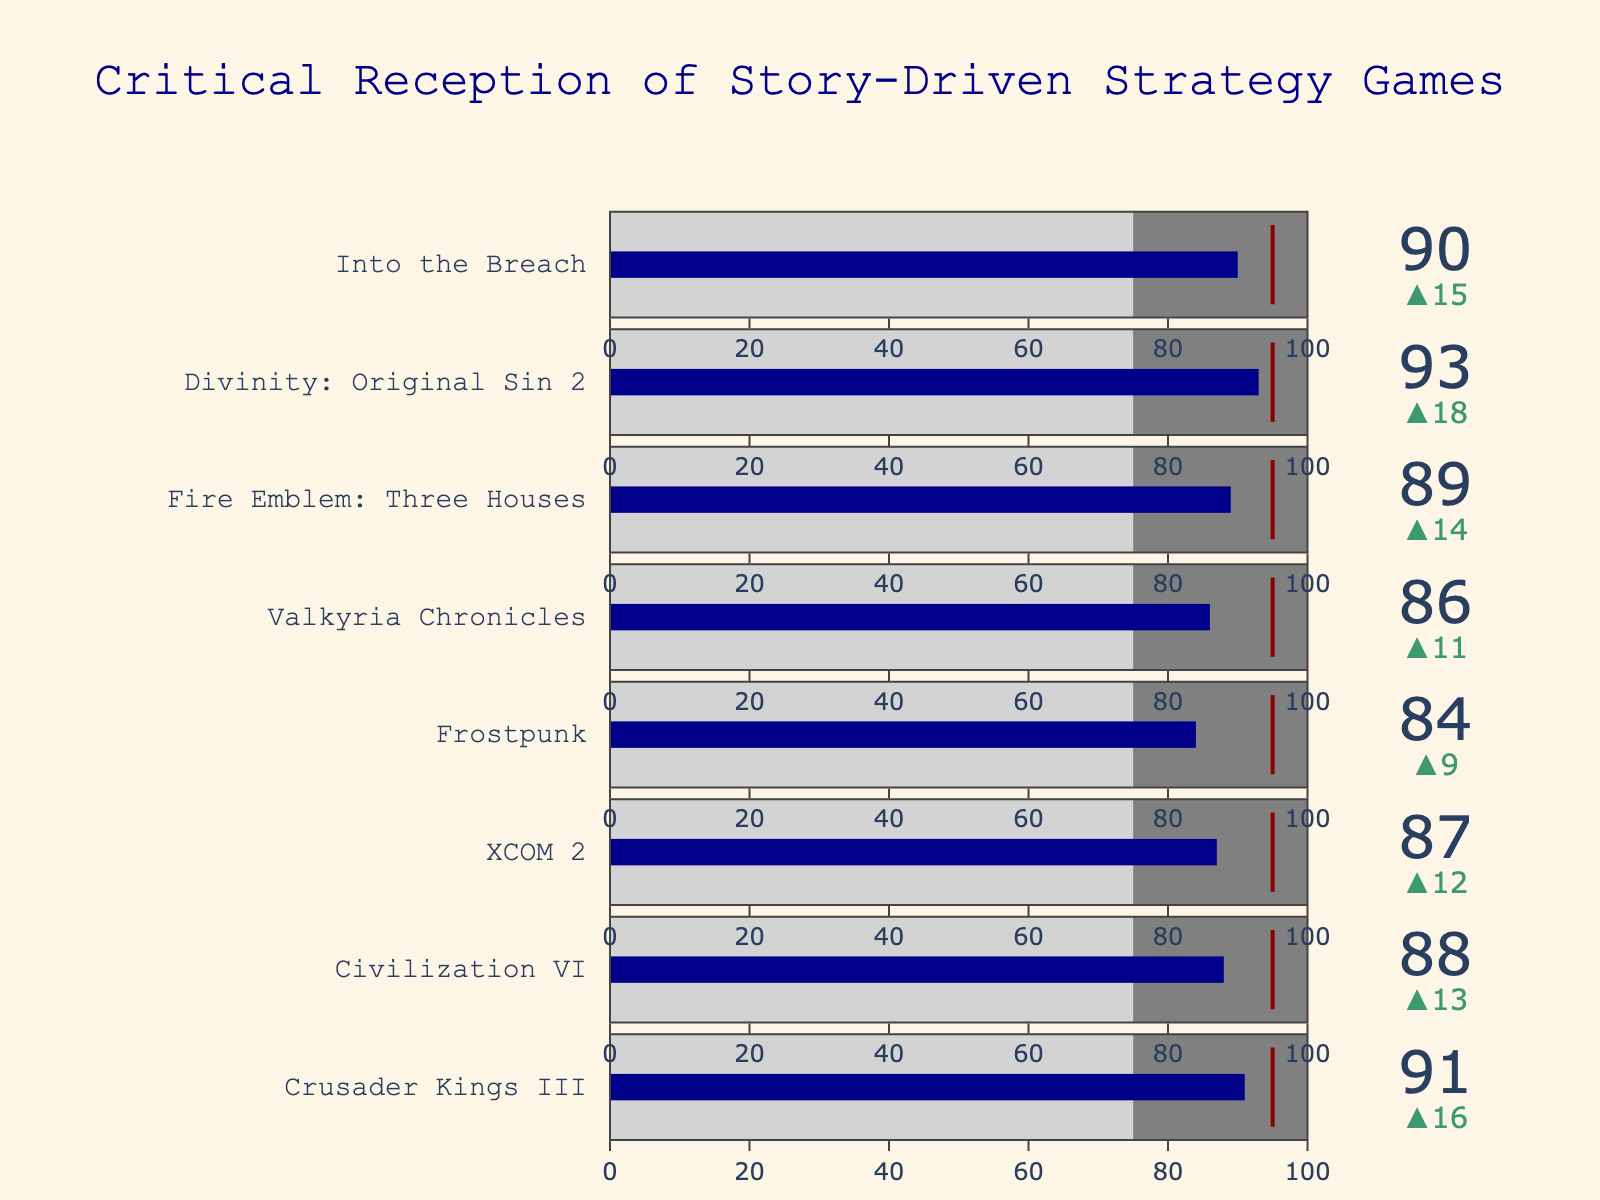How many games are listed with their critical reception scores in the figure? Count the number of distinct gauges in the Bullet Chart. Each gauge corresponds to one game.
Answer: 8 What game has the highest Metacritic Score? Look for the game with the highest bar value on the gauges.
Answer: Divinity: Original Sin 2 Which game's Metacritic Score is closest to the notable story-driven strategy game benchmark? Compare each game's Metacritic Score with the benchmark value of 95.
Answer: Crusader Kings III How much higher is Civilization VI's Metacritic Score compared to the industry average? Subtract the industry average (75) from Civilization VI's score (88).
Answer: 13 What is the range of Metacritic Scores among the listed games? Identify the minimum and maximum Metacritic Scores from the list, then calculate the difference between them.
Answer: 93 - 84 = 9 Which game is closest to reaching the notable story-driven strategy game benchmark, in terms of Metacritic Score? Determine the difference between each game's Metacritic Score and the benchmark. The game with the smallest difference is the closest.
Answer: Crusader Kings III (only 4 points away from 95) How does XCOM 2's Metacritic Score compare to Frostpunk's? Compare the values directly from the gauges: XCOM 2 has a score of 87, and Frostpunk has a score of 84.
Answer: XCOM 2 is 3 points higher What is the median Metacritic Score of the listed games? List all the Metacritic Scores in ascending order and find the middle value. If there's an even number of scores, take the average of the two middle ones.
Answer: (87+88)/2 = 87.5 Which game shows the largest positive delta from the industry average? Identify the gauge with the largest delta value from their industry average (75).
Answer: Divinity: Original Sin 2 (18 points) On average, how much do the Metacritic Scores exceed the industry average? Find the average Metacritic Score of all games, then subtract the industry average from this average.
Answer: Average Metacritic Score is (91+88+87+84+86+89+93+90)/8 = 88.5, so average excess is 88.5 - 75 = 13.5 